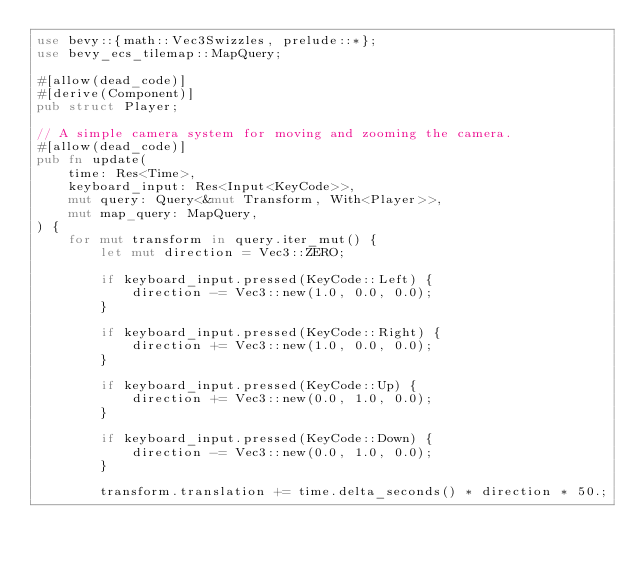Convert code to text. <code><loc_0><loc_0><loc_500><loc_500><_Rust_>use bevy::{math::Vec3Swizzles, prelude::*};
use bevy_ecs_tilemap::MapQuery;

#[allow(dead_code)]
#[derive(Component)]
pub struct Player;

// A simple camera system for moving and zooming the camera.
#[allow(dead_code)]
pub fn update(
    time: Res<Time>,
    keyboard_input: Res<Input<KeyCode>>,
    mut query: Query<&mut Transform, With<Player>>,
    mut map_query: MapQuery,
) {
    for mut transform in query.iter_mut() {
        let mut direction = Vec3::ZERO;

        if keyboard_input.pressed(KeyCode::Left) {
            direction -= Vec3::new(1.0, 0.0, 0.0);
        }

        if keyboard_input.pressed(KeyCode::Right) {
            direction += Vec3::new(1.0, 0.0, 0.0);
        }

        if keyboard_input.pressed(KeyCode::Up) {
            direction += Vec3::new(0.0, 1.0, 0.0);
        }

        if keyboard_input.pressed(KeyCode::Down) {
            direction -= Vec3::new(0.0, 1.0, 0.0);
        }

        transform.translation += time.delta_seconds() * direction * 50.;
</code> 